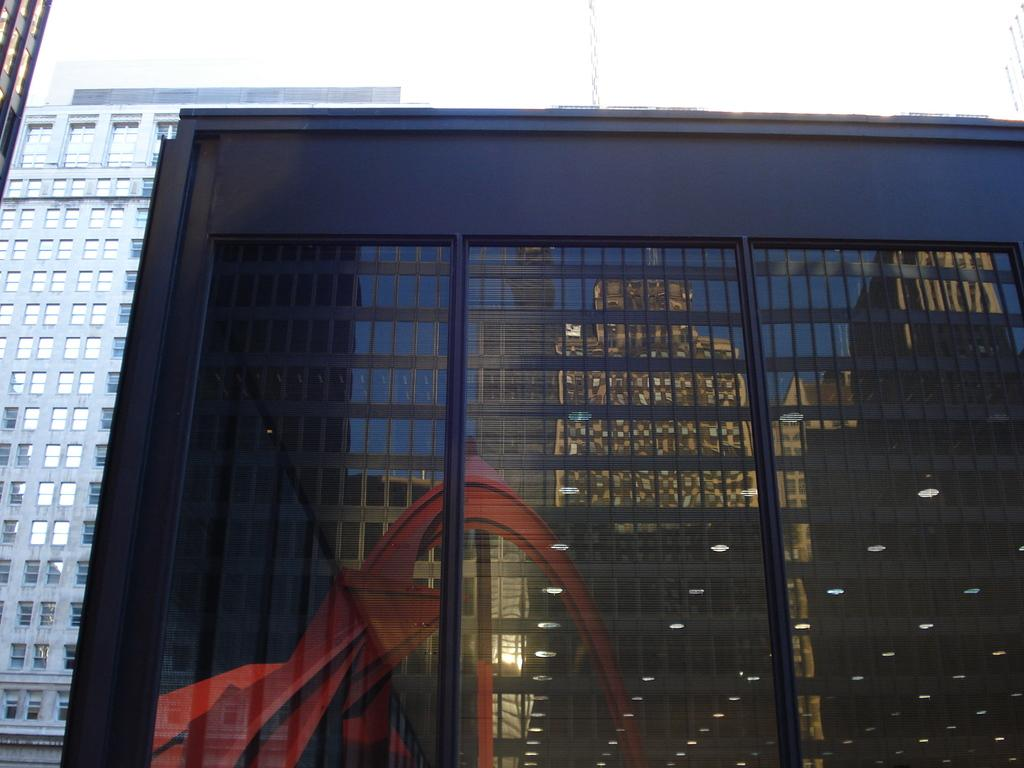What type of structures can be seen in the image? There are buildings in the image. Can you describe a specific building in the image? There is a building with glass walls in the image. What effect do the glass walls have on the image? The glass walls reflect other buildings and lights in the image. What is visible at the top of the image? The sky is visible at the top of the image. How many trains can be seen passing through the buildings in the image? There are no trains visible in the image; it only features buildings and their reflections. 